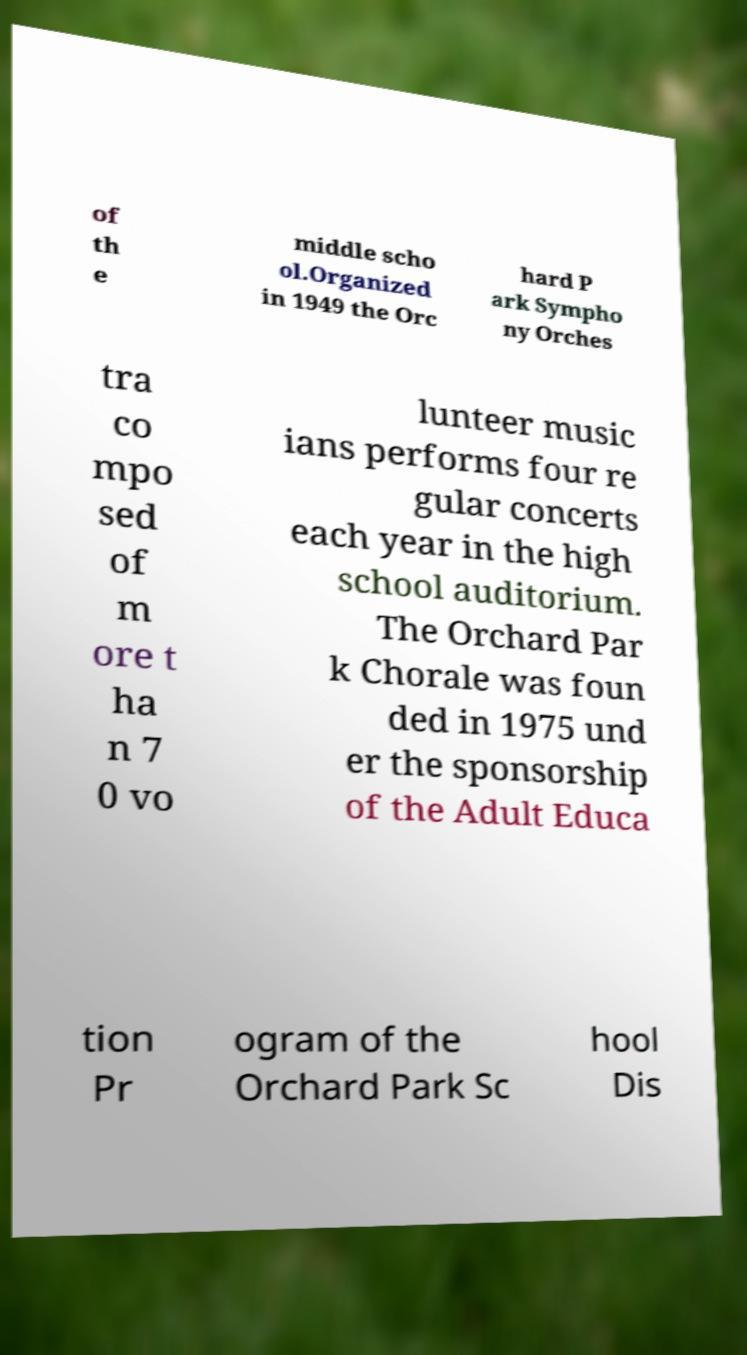Could you assist in decoding the text presented in this image and type it out clearly? of th e middle scho ol.Organized in 1949 the Orc hard P ark Sympho ny Orches tra co mpo sed of m ore t ha n 7 0 vo lunteer music ians performs four re gular concerts each year in the high school auditorium. The Orchard Par k Chorale was foun ded in 1975 und er the sponsorship of the Adult Educa tion Pr ogram of the Orchard Park Sc hool Dis 